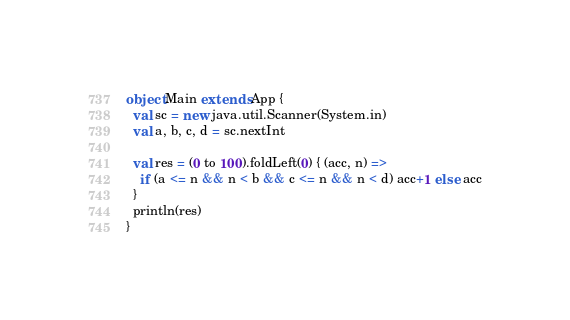<code> <loc_0><loc_0><loc_500><loc_500><_Scala_>object Main extends App {
  val sc = new java.util.Scanner(System.in)
  val a, b, c, d = sc.nextInt

  val res = (0 to 100).foldLeft(0) { (acc, n) =>
    if (a <= n && n < b && c <= n && n < d) acc+1 else acc
  }
  println(res)
}</code> 